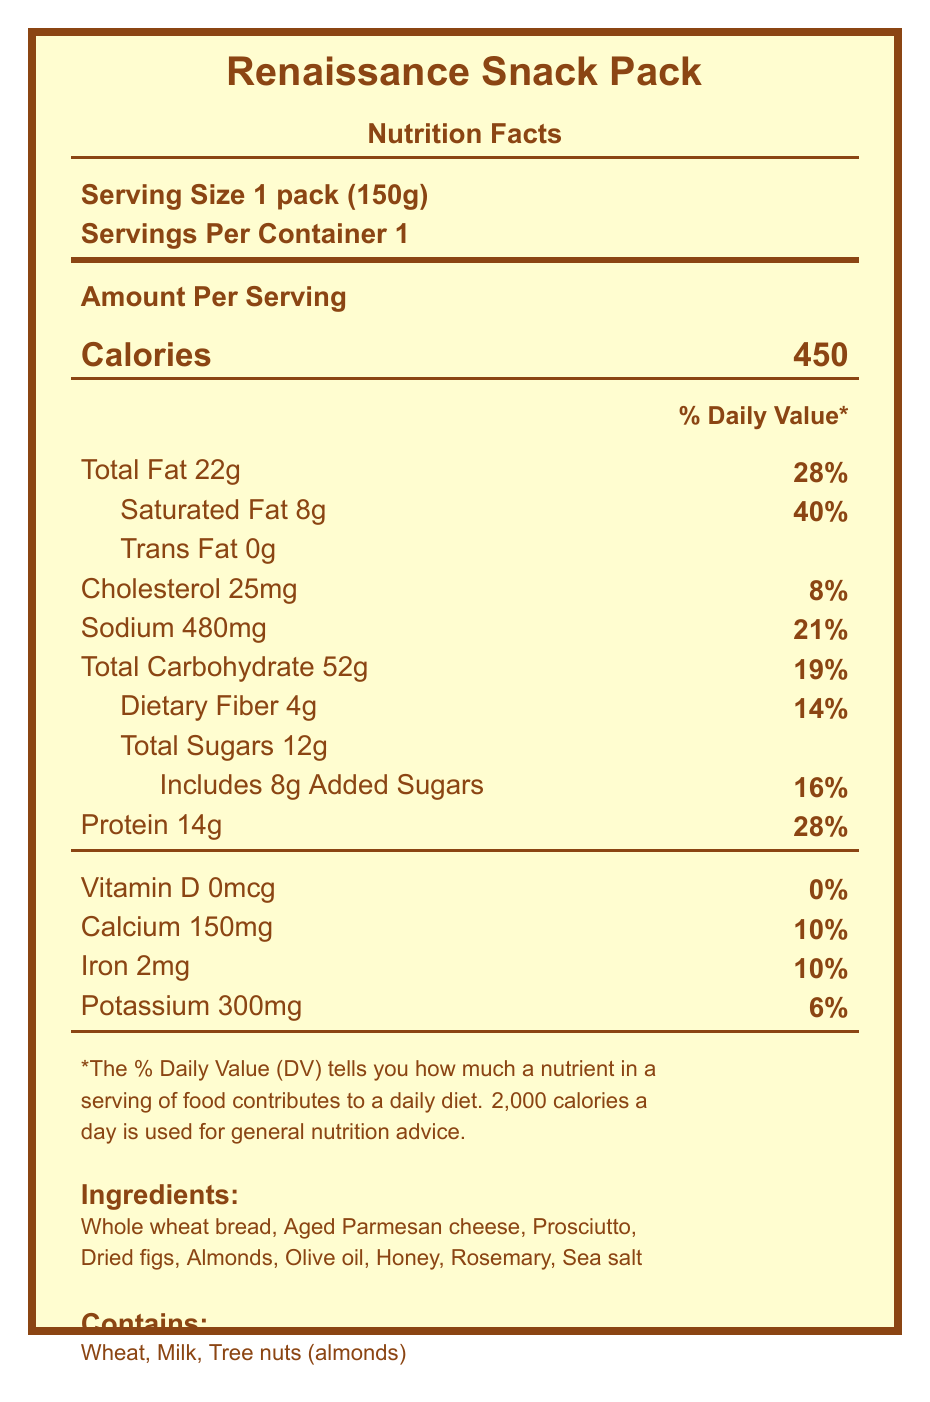what is the serving size of the "Renaissance Snack Pack"? The serving size is mentioned at the beginning of the document under "Serving Size 1 pack (150g)".
Answer: 1 pack (150g) how much saturated fat does the "Renaissance Snack Pack" contain? The amount of saturated fat is listed as 8g in the section for fats.
Answer: 8g what is the total carbohydrate content per serving? The total carbohydrate content per serving is listed as 52g.
Answer: 52g what ingredients are included in the "Renaissance Snack Pack"? The document lists these ingredients under the "Ingredients" section.
Answer: Whole wheat bread, Aged Parmesan cheese, Prosciutto, Dried figs, Almonds, Olive oil, Honey, Rosemary, Sea salt how much added sugars are in the "Renaissance Snack Pack"? The amount of added sugars is specified as 8g in the document.
Answer: 8g What is the percentage of the daily value for sodium in the "Renaissance Snack Pack"? A. 8% B. 14% C. 21% D. 40% The document states that the sodium content provides 21% of the daily value.
Answer: C. 21% How much protein does the "Renaissance Snack Pack" provide? A. 8g B. 10g C. 14g D. 22g The protein amount is listed as 14g in the nutrition facts.
Answer: C. 14g Does the "Renaissance Snack Pack" contain any trans fat? The nutrition facts state that trans fat is 0g.
Answer: No What are the three allergen warnings listed for the "Renaissance Snack Pack"? The allergens are listed as wheat, milk, and tree nuts (almonds) in the allergens section.
Answer: Wheat, Milk, Tree nuts (almonds) Describe the "Renaissance Snack Pack" nutrition facts document. The document is a Nutrition Facts label outlining various dietary details. It includes serving size, calorie count, and nutrient amounts with their respective daily value percentages. Allergy information and the list of ingredients are provided. The design is styled with Renaissance-themed colors and fonts.
Answer: The document provides the nutritional breakdown of the "Renaissance Snack Pack," including serving size, calories, and percentages of daily values for various nutrients such as fats, cholesterol, sodium, carbohydrates, and protein. It lists ingredients, allergen information, and includes design elements in renaissance aesthetics. Is the "Renaissance Snack Pack" considered high in saturated fat? The pack has 8g of saturated fat, which is 40% of the daily value, indicating a high content.
Answer: Yes How are the ingredients of the "Renaissance Snack Pack" sourced? The document does not provide detailed sourcing information for the ingredients.
Answer: Not enough information How many grams of dietary fiber are in the "Renaissance Snack Pack"? The dietary fiber content is listed as 4g.
Answer: 4g Do Renaissance Snack Packs include Vitamin D? The document lists Vitamin D as 0mcg, which means it does not contain Vitamin D.
Answer: No What interactive feature does the "Renaissance Snack Pack" offer? A. Virtual map B. Interactive storytelling C. AR cooking utensils D. Music playlist The document mentions augmented reality for viewing 3D models of Renaissance cooking utensils.
Answer: C. AR cooking utensils What is the calcium content of the "Renaissance Snack Pack" in milligrams and its daily value percentage? The document states that the calcium content is 150mg with a daily value of 10%.
Answer: 150mg, 10% 